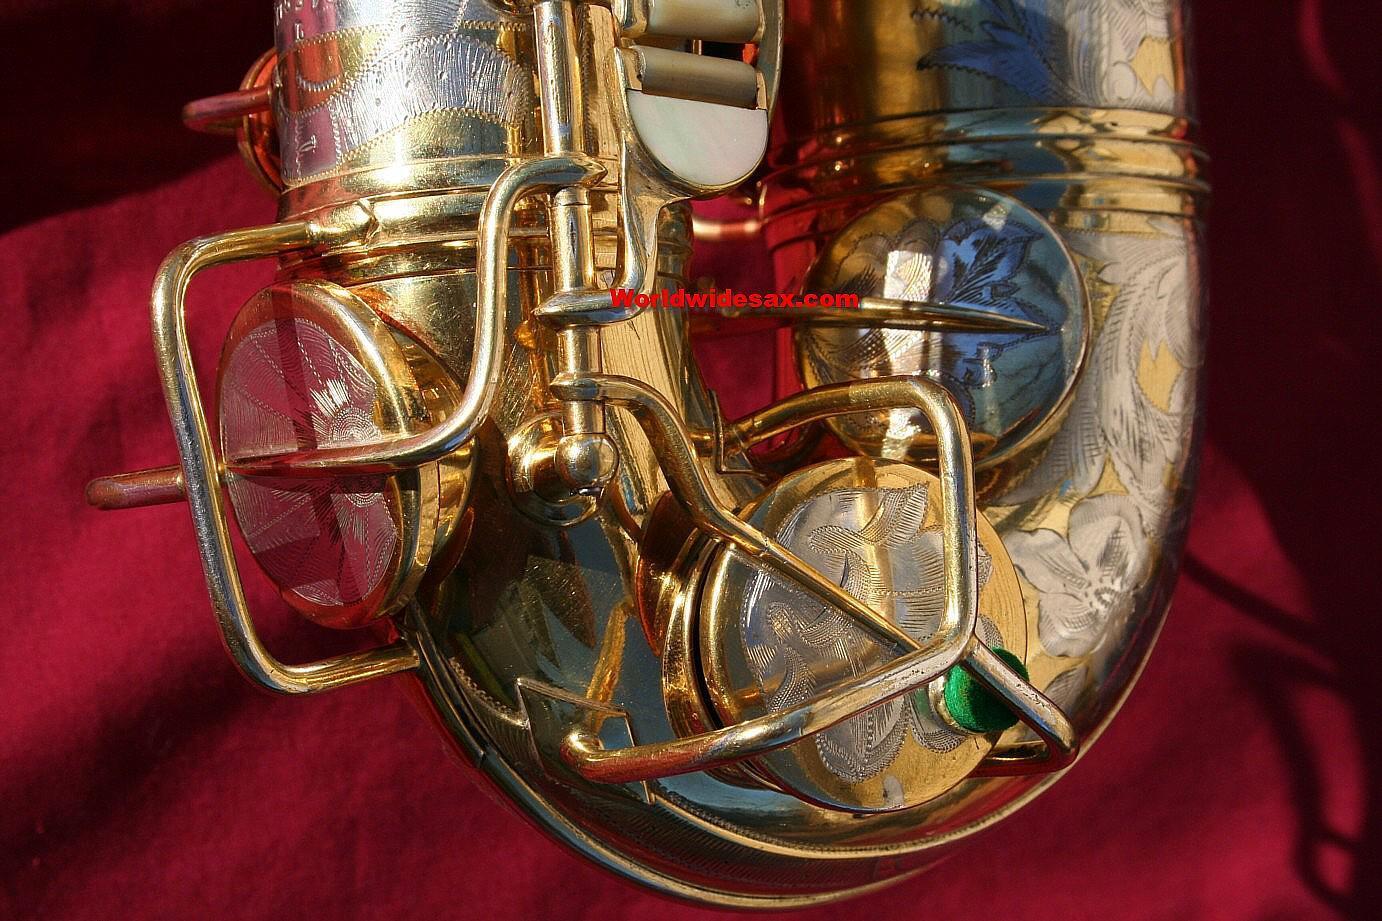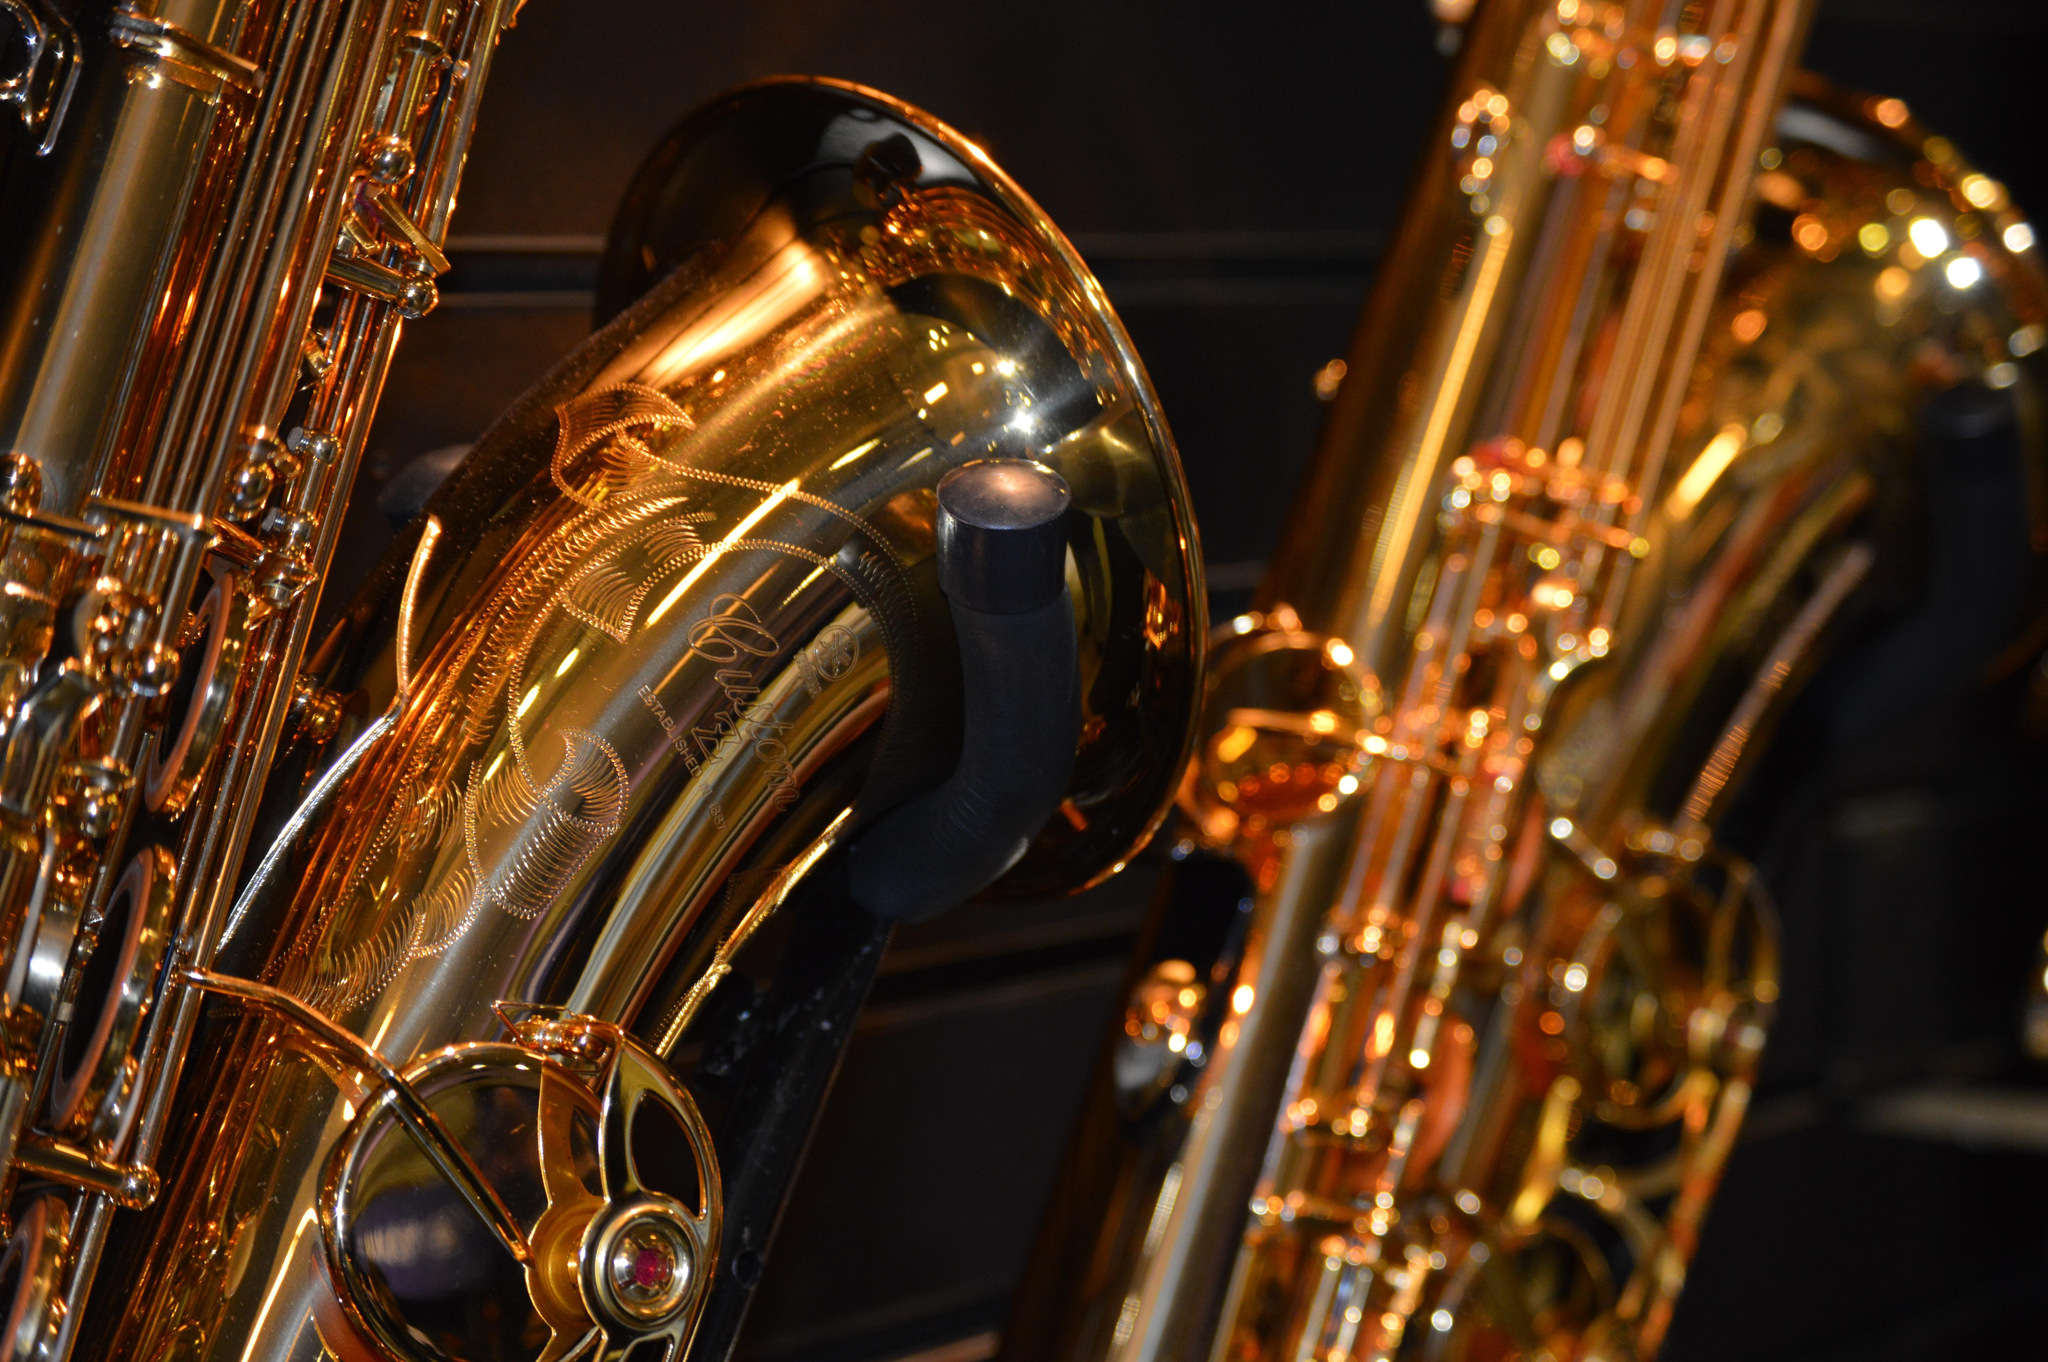The first image is the image on the left, the second image is the image on the right. Considering the images on both sides, is "One image shows a single rightward facing bell of a saxophone, and the other image shows a gold-colored leftward-facing saxophone in the foreground." valid? Answer yes or no. No. The first image is the image on the left, the second image is the image on the right. Evaluate the accuracy of this statement regarding the images: "At least one saxophone has engraving on the surface of its body.". Is it true? Answer yes or no. Yes. 